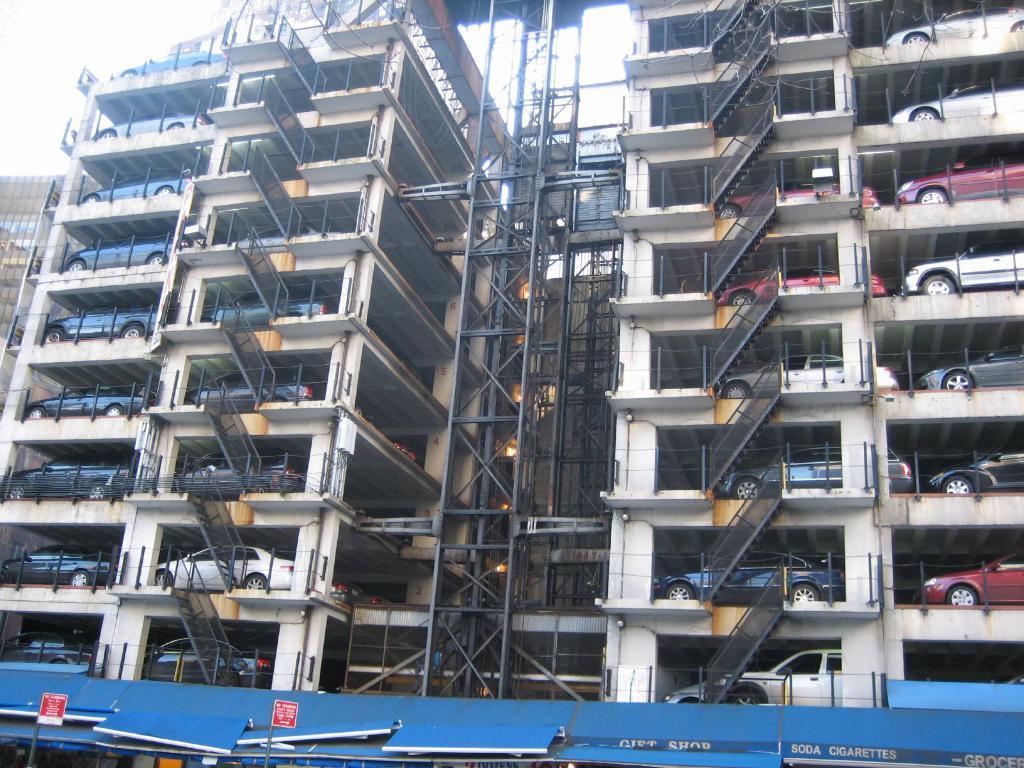Please provide a concise description of this image. In this image we can see parking lots, iron grills and sky. 